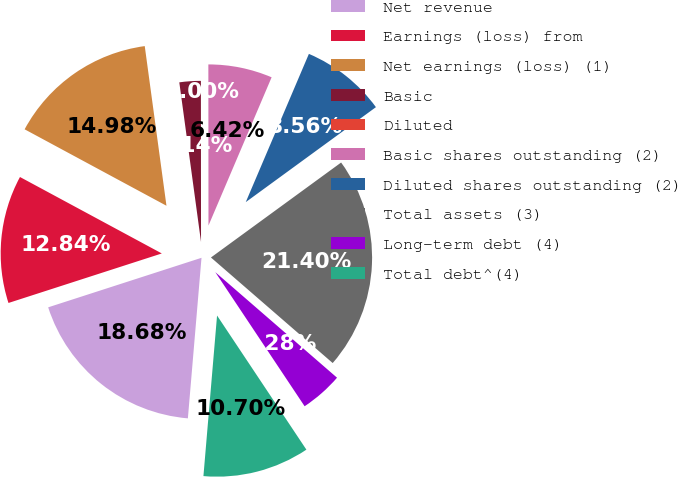Convert chart to OTSL. <chart><loc_0><loc_0><loc_500><loc_500><pie_chart><fcel>Net revenue<fcel>Earnings (loss) from<fcel>Net earnings (loss) (1)<fcel>Basic<fcel>Diluted<fcel>Basic shares outstanding (2)<fcel>Diluted shares outstanding (2)<fcel>Total assets (3)<fcel>Long-term debt (4)<fcel>Total debt^(4)<nl><fcel>18.68%<fcel>12.84%<fcel>14.98%<fcel>2.14%<fcel>0.0%<fcel>6.42%<fcel>8.56%<fcel>21.4%<fcel>4.28%<fcel>10.7%<nl></chart> 